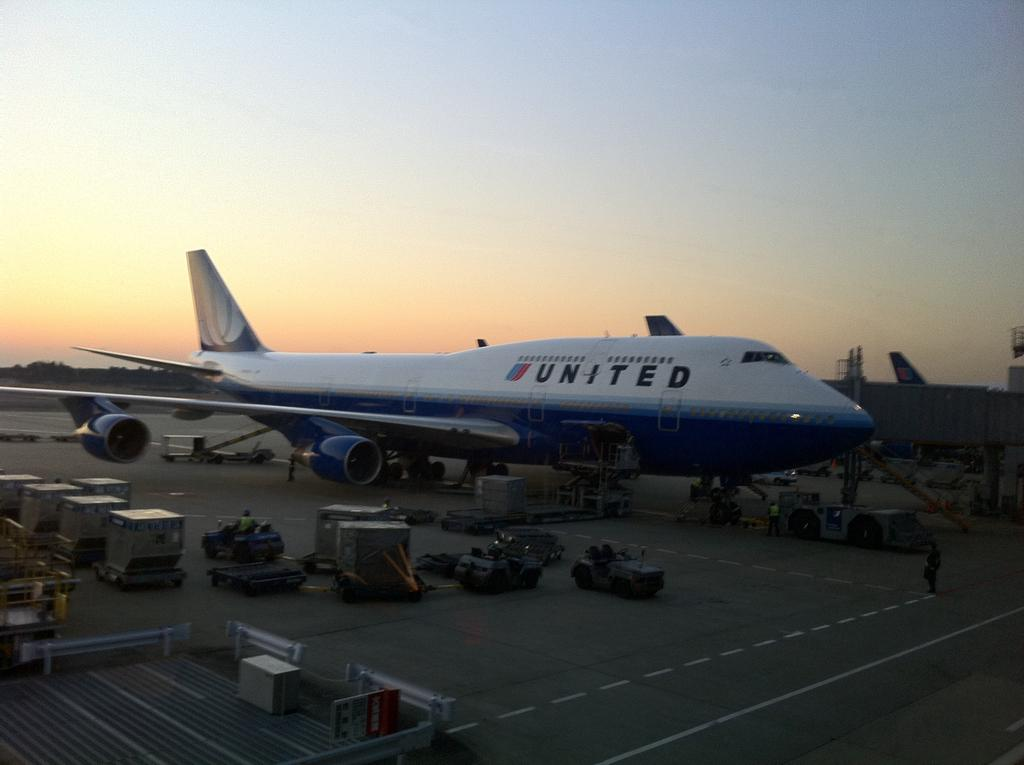<image>
Share a concise interpretation of the image provided. The plane shown  is a United airlines 747 at the airport. 